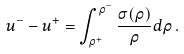Convert formula to latex. <formula><loc_0><loc_0><loc_500><loc_500>u ^ { - } - u ^ { + } = \int _ { \rho ^ { + } } ^ { \rho ^ { - } } \frac { \sigma ( \rho ) } { \rho } d \rho \, .</formula> 